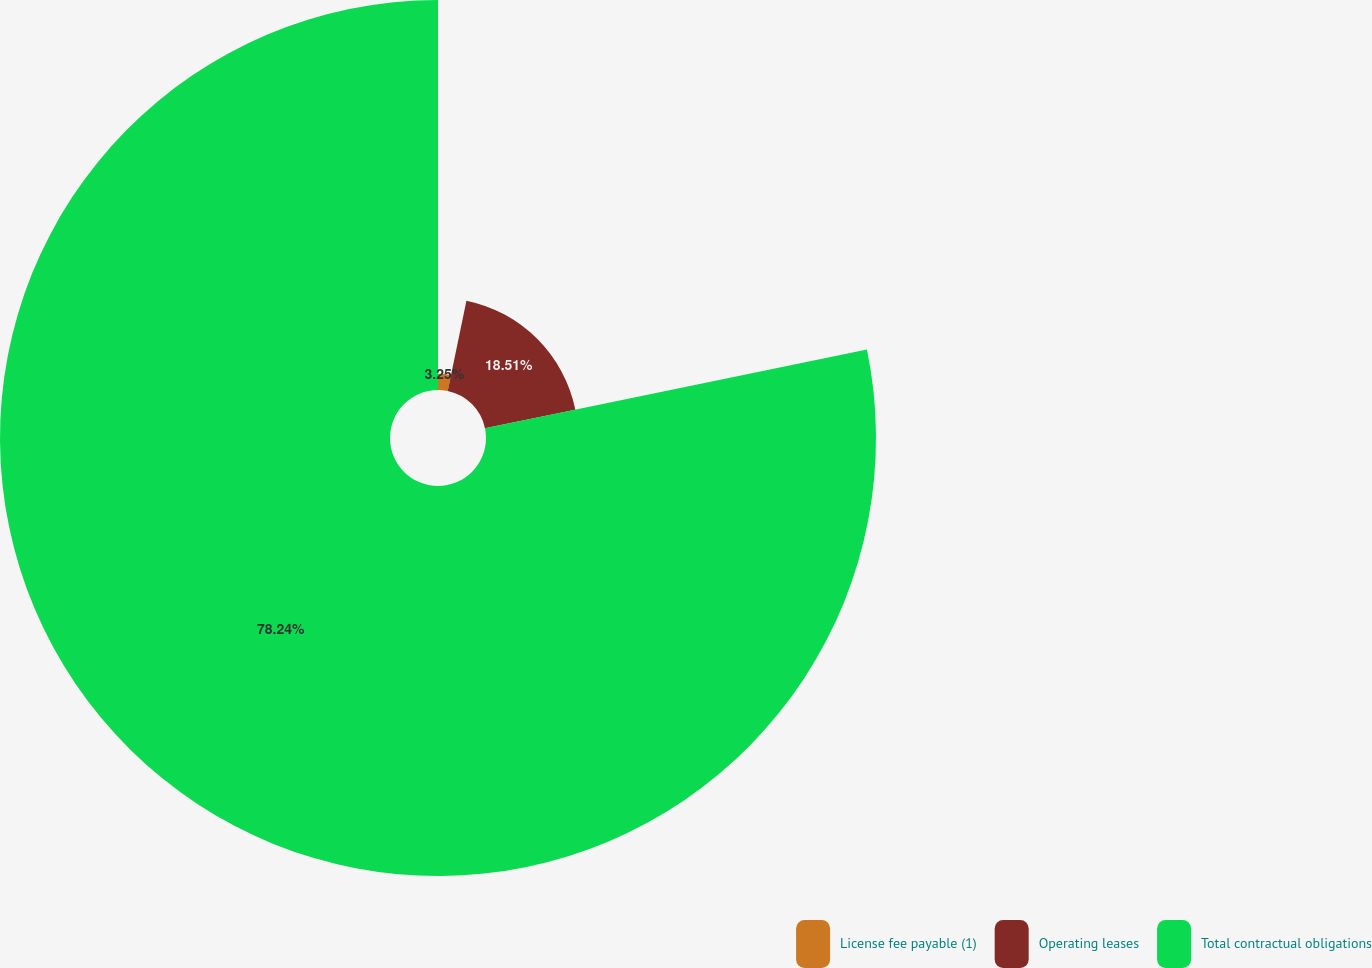Convert chart to OTSL. <chart><loc_0><loc_0><loc_500><loc_500><pie_chart><fcel>License fee payable (1)<fcel>Operating leases<fcel>Total contractual obligations<nl><fcel>3.25%<fcel>18.51%<fcel>78.25%<nl></chart> 